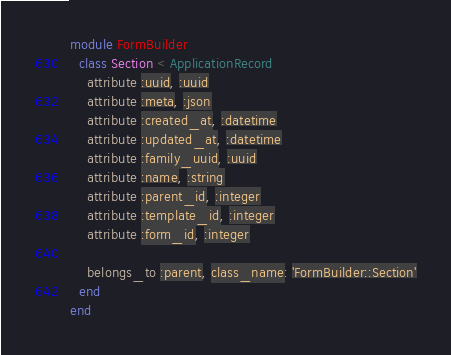Convert code to text. <code><loc_0><loc_0><loc_500><loc_500><_Ruby_>module FormBuilder
  class Section < ApplicationRecord
    attribute :uuid, :uuid
    attribute :meta, :json
    attribute :created_at, :datetime
    attribute :updated_at, :datetime
    attribute :family_uuid, :uuid
    attribute :name, :string
    attribute :parent_id, :integer
    attribute :template_id, :integer
    attribute :form_id, :integer

    belongs_to :parent, class_name: 'FormBuilder::Section'
  end
end
</code> 